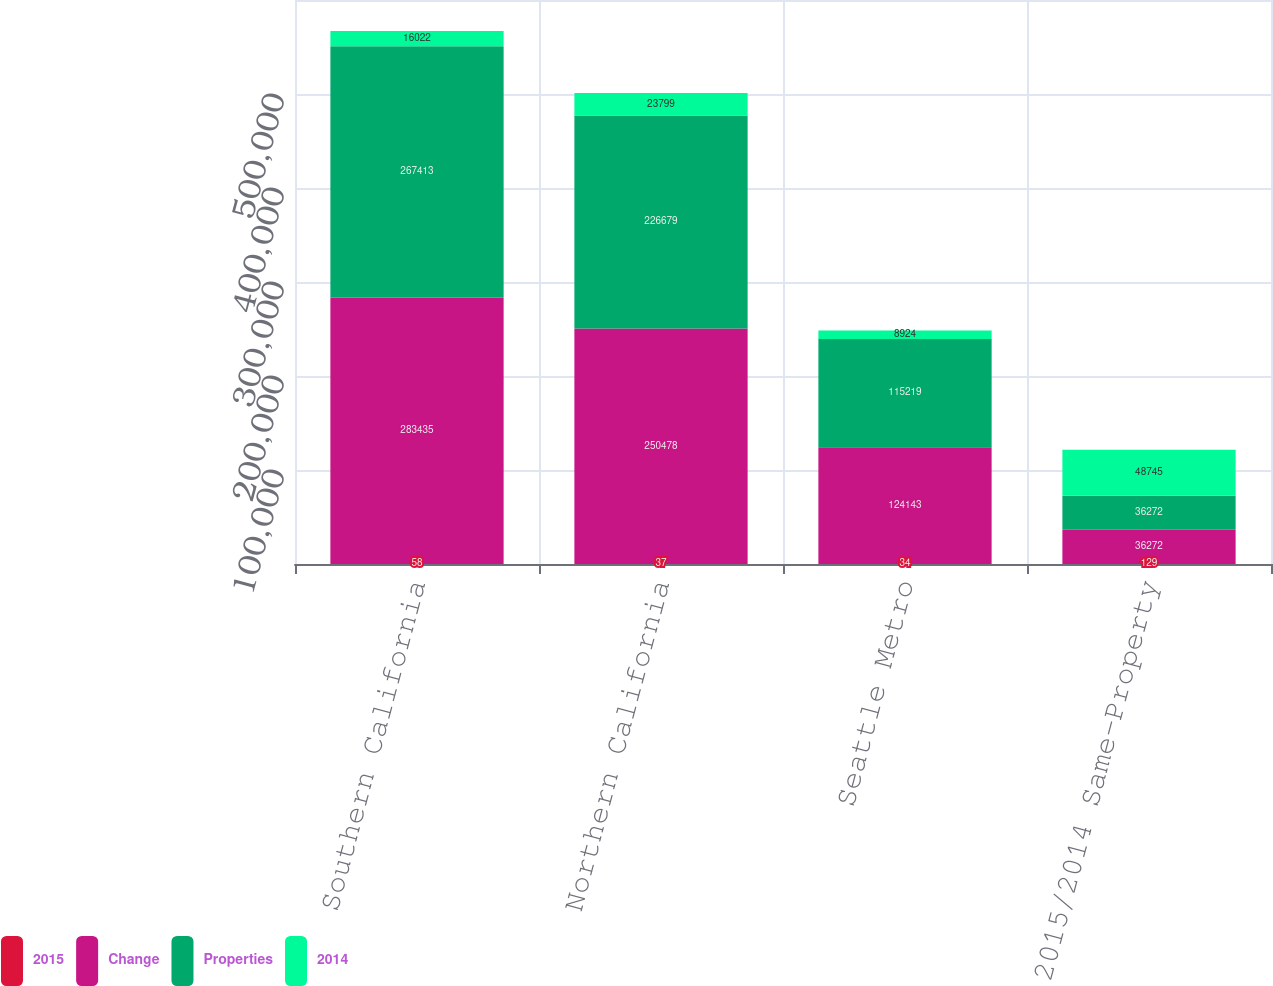Convert chart to OTSL. <chart><loc_0><loc_0><loc_500><loc_500><stacked_bar_chart><ecel><fcel>Southern California<fcel>Northern California<fcel>Seattle Metro<fcel>Total 2015/2014 Same-Property<nl><fcel>2015<fcel>58<fcel>37<fcel>34<fcel>129<nl><fcel>Change<fcel>283435<fcel>250478<fcel>124143<fcel>36272<nl><fcel>Properties<fcel>267413<fcel>226679<fcel>115219<fcel>36272<nl><fcel>2014<fcel>16022<fcel>23799<fcel>8924<fcel>48745<nl></chart> 